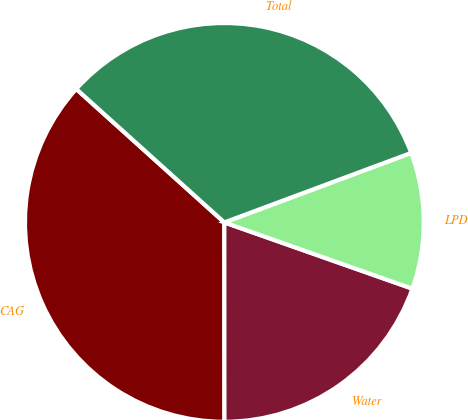<chart> <loc_0><loc_0><loc_500><loc_500><pie_chart><fcel>CAG<fcel>Water<fcel>LPD<fcel>Total<nl><fcel>36.68%<fcel>19.6%<fcel>11.06%<fcel>32.66%<nl></chart> 